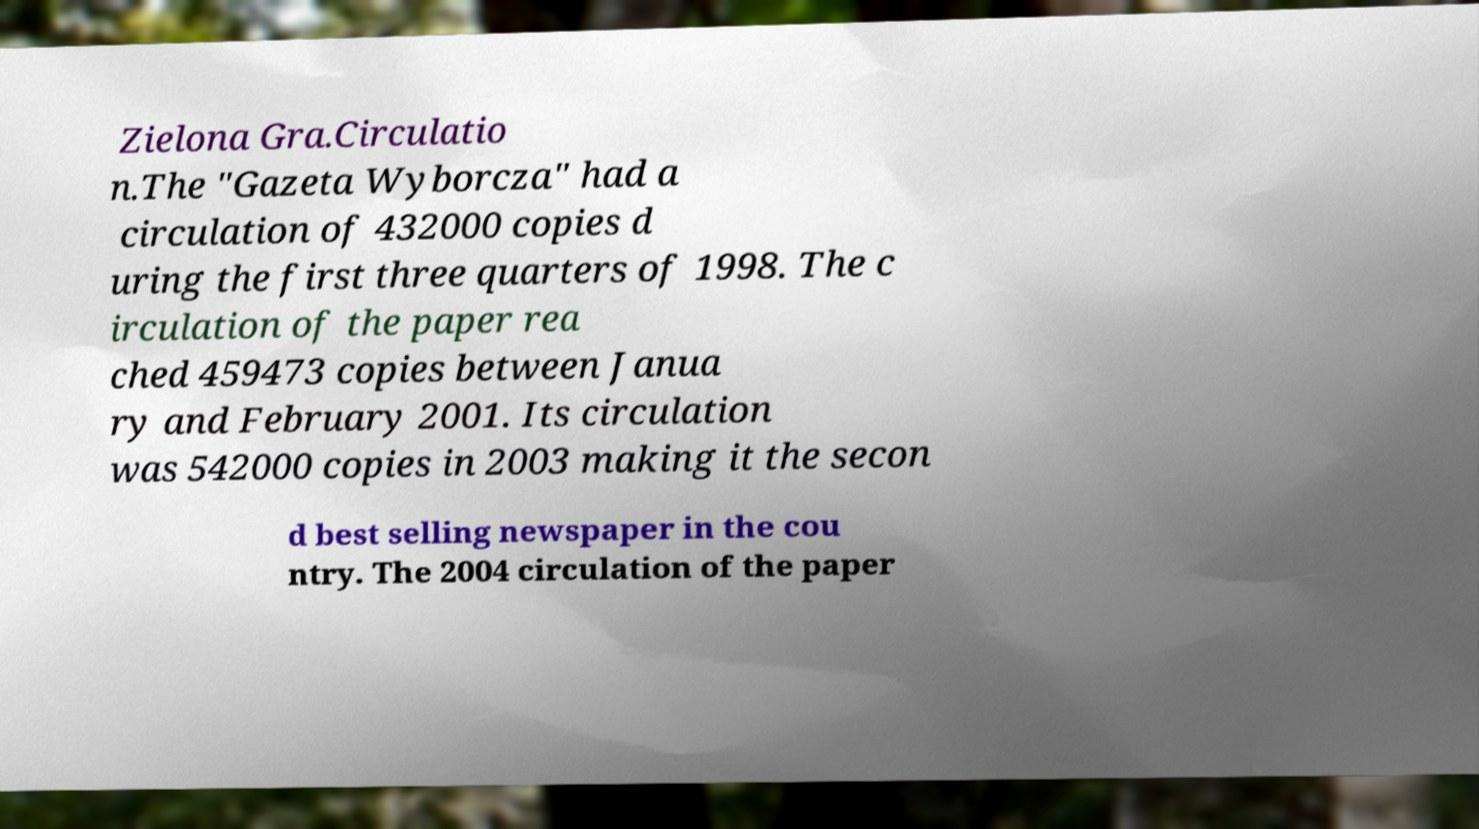What messages or text are displayed in this image? I need them in a readable, typed format. Zielona Gra.Circulatio n.The "Gazeta Wyborcza" had a circulation of 432000 copies d uring the first three quarters of 1998. The c irculation of the paper rea ched 459473 copies between Janua ry and February 2001. Its circulation was 542000 copies in 2003 making it the secon d best selling newspaper in the cou ntry. The 2004 circulation of the paper 